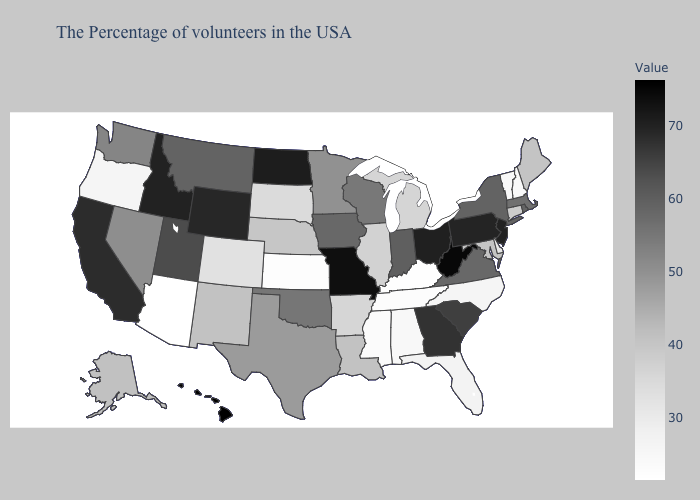Does Maryland have a lower value than Iowa?
Keep it brief. Yes. Which states have the highest value in the USA?
Write a very short answer. Hawaii. Does Mississippi have the lowest value in the USA?
Quick response, please. No. Does the map have missing data?
Answer briefly. No. Among the states that border Utah , which have the lowest value?
Be succinct. Arizona. Which states have the lowest value in the USA?
Short answer required. Arizona. Among the states that border New Hampshire , which have the highest value?
Write a very short answer. Massachusetts. 